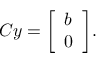Convert formula to latex. <formula><loc_0><loc_0><loc_500><loc_500>C y = { \left [ \begin{array} { l } { b } \\ { 0 } \end{array} \right ] } .</formula> 